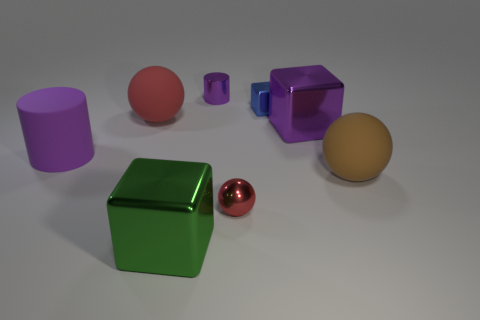Add 2 tiny red metal objects. How many objects exist? 10 Subtract all cylinders. How many objects are left? 6 Subtract 1 green cubes. How many objects are left? 7 Subtract all small yellow rubber cylinders. Subtract all large brown matte spheres. How many objects are left? 7 Add 3 large purple objects. How many large purple objects are left? 5 Add 6 rubber cylinders. How many rubber cylinders exist? 7 